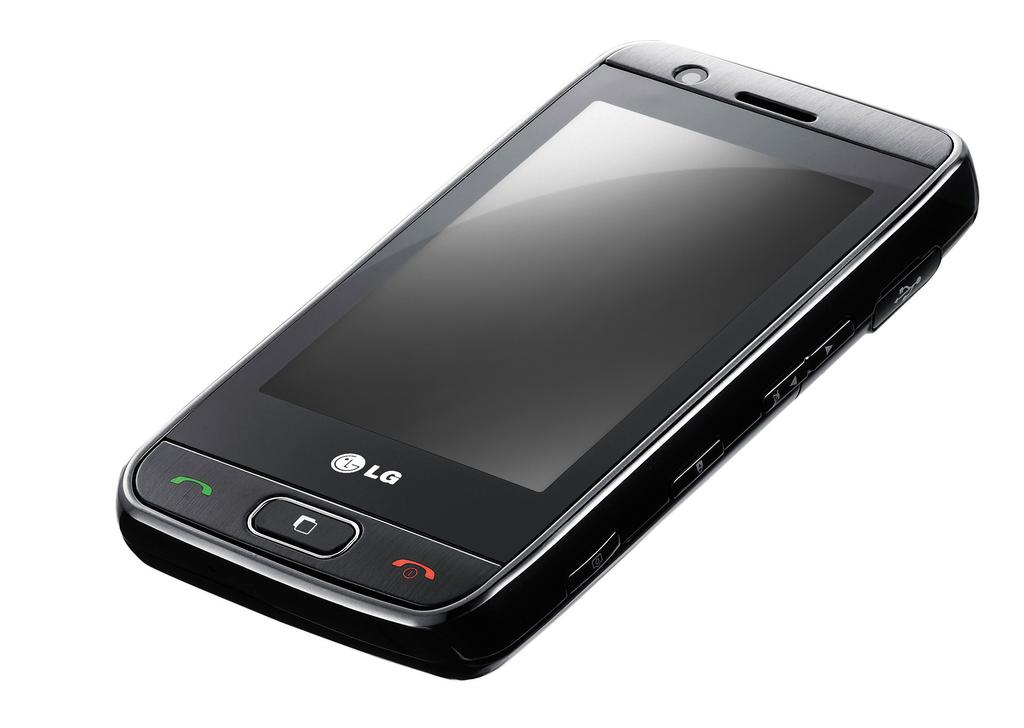<image>
Render a clear and concise summary of the photo. a smart phone with LG written on the bottom 